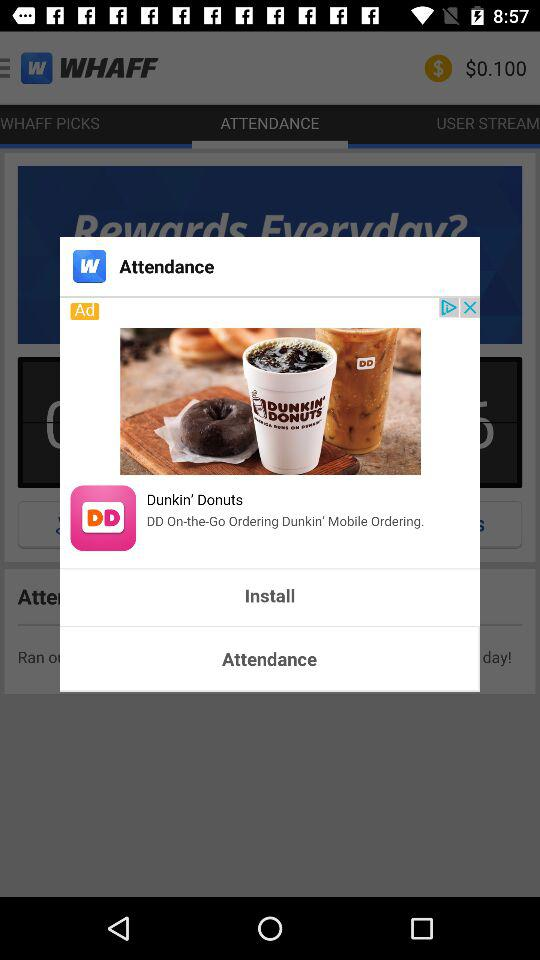How much does a cup of coffee cost at Dunkin' Donuts?
When the provided information is insufficient, respond with <no answer>. <no answer> 